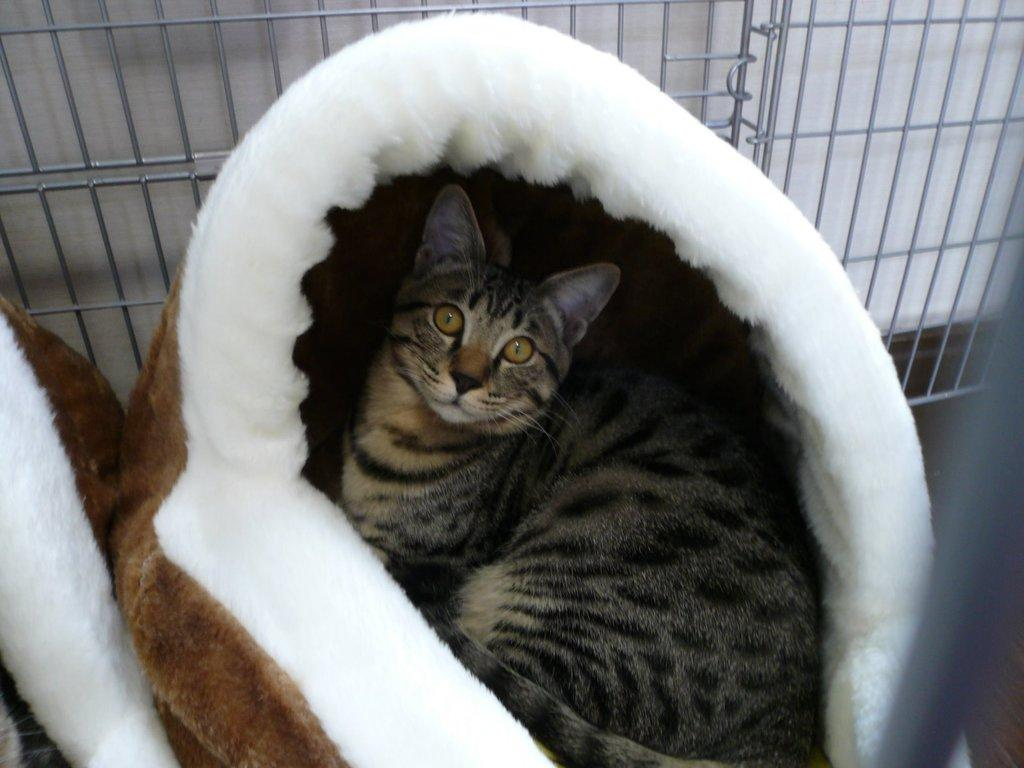What type of animal is present in the image? There is a cat in the image. Where is the cat located in the image? The cat is sitting in an object. Can you describe any other objects in the image? There is a metal object in the image. How much dirt is visible on the road in the image? There is no road or dirt present in the image; it features a cat sitting in an object and a metal object. What advice does the father give to the cat in the image? There is no father or interaction between a father and the cat in the image. 